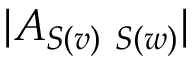Convert formula to latex. <formula><loc_0><loc_0><loc_500><loc_500>| A _ { S ( v ) \ S ( w ) } |</formula> 